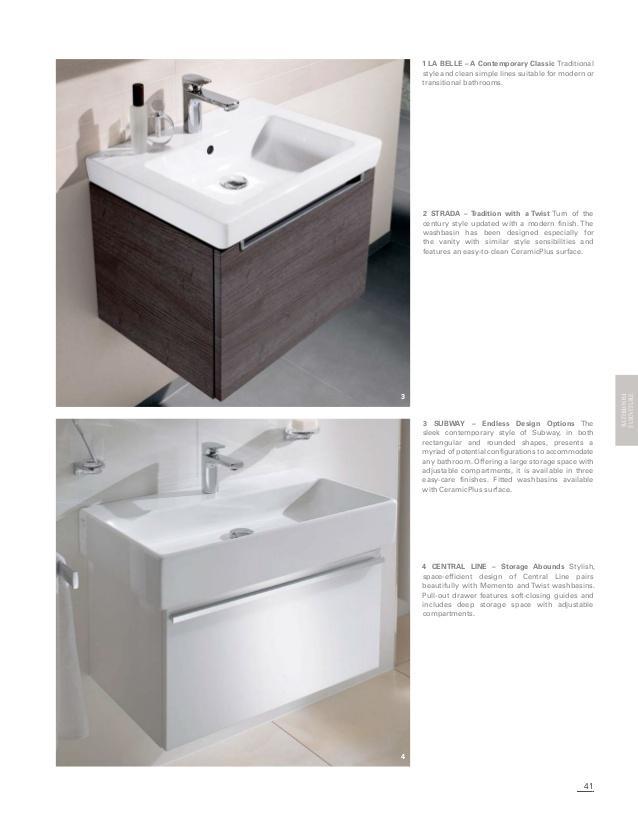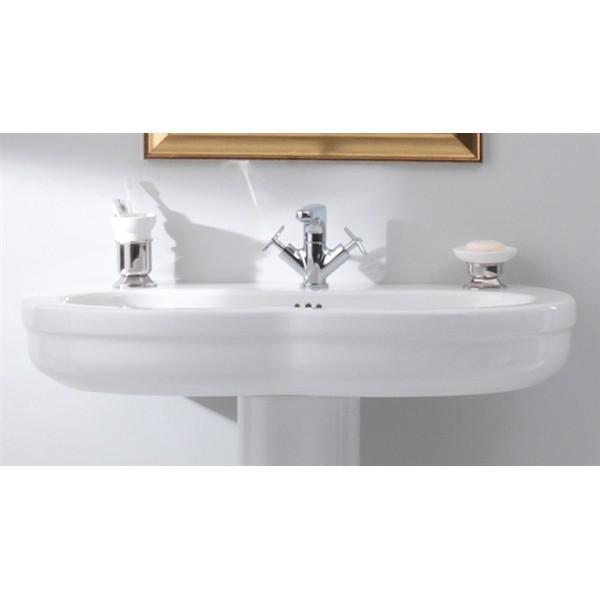The first image is the image on the left, the second image is the image on the right. For the images shown, is this caption "IN at least one image there is a square white water basin on top of a dark wooden shelve." true? Answer yes or no. Yes. The first image is the image on the left, the second image is the image on the right. Examine the images to the left and right. Is the description "There are three faucets." accurate? Answer yes or no. Yes. 